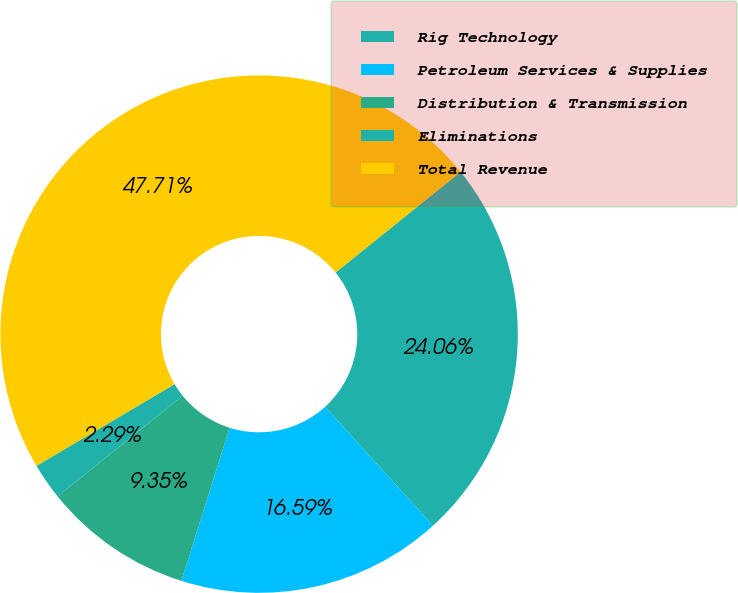<chart> <loc_0><loc_0><loc_500><loc_500><pie_chart><fcel>Rig Technology<fcel>Petroleum Services & Supplies<fcel>Distribution & Transmission<fcel>Eliminations<fcel>Total Revenue<nl><fcel>24.06%<fcel>16.59%<fcel>9.35%<fcel>2.29%<fcel>47.71%<nl></chart> 